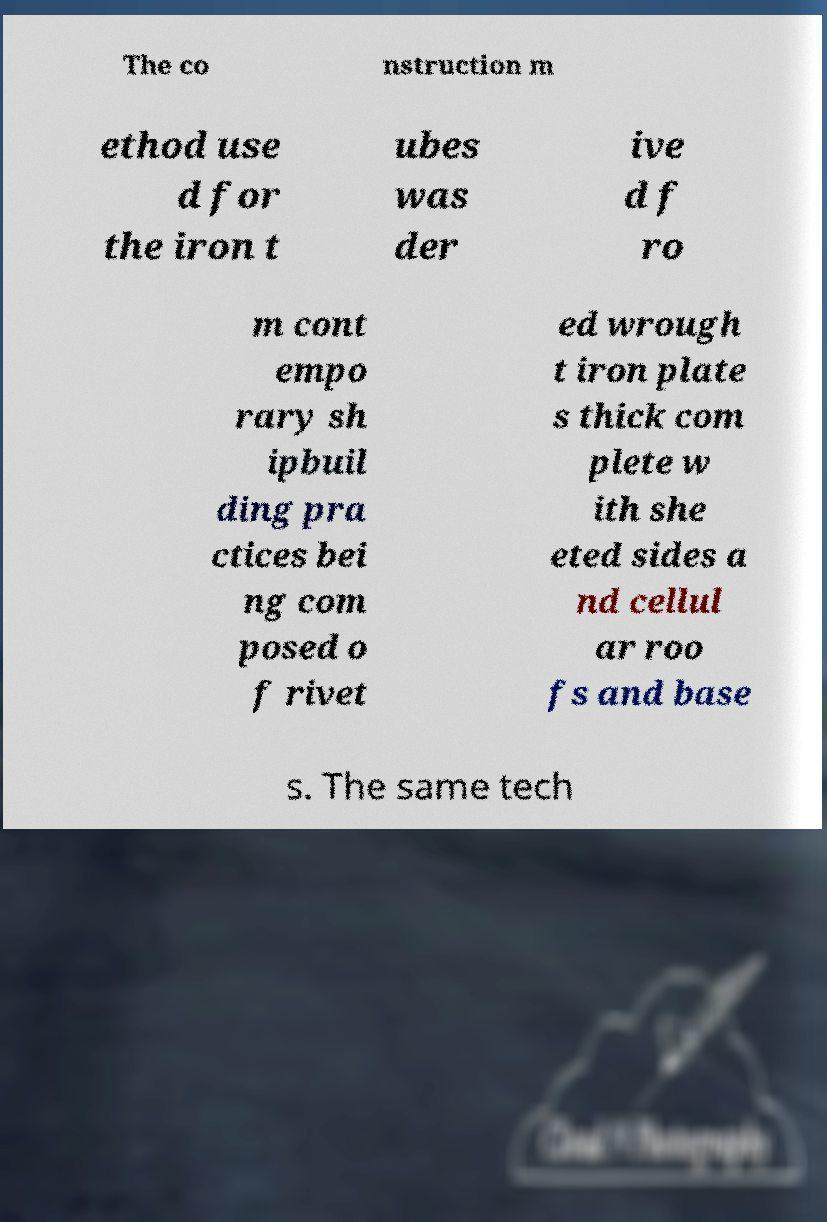For documentation purposes, I need the text within this image transcribed. Could you provide that? The co nstruction m ethod use d for the iron t ubes was der ive d f ro m cont empo rary sh ipbuil ding pra ctices bei ng com posed o f rivet ed wrough t iron plate s thick com plete w ith she eted sides a nd cellul ar roo fs and base s. The same tech 